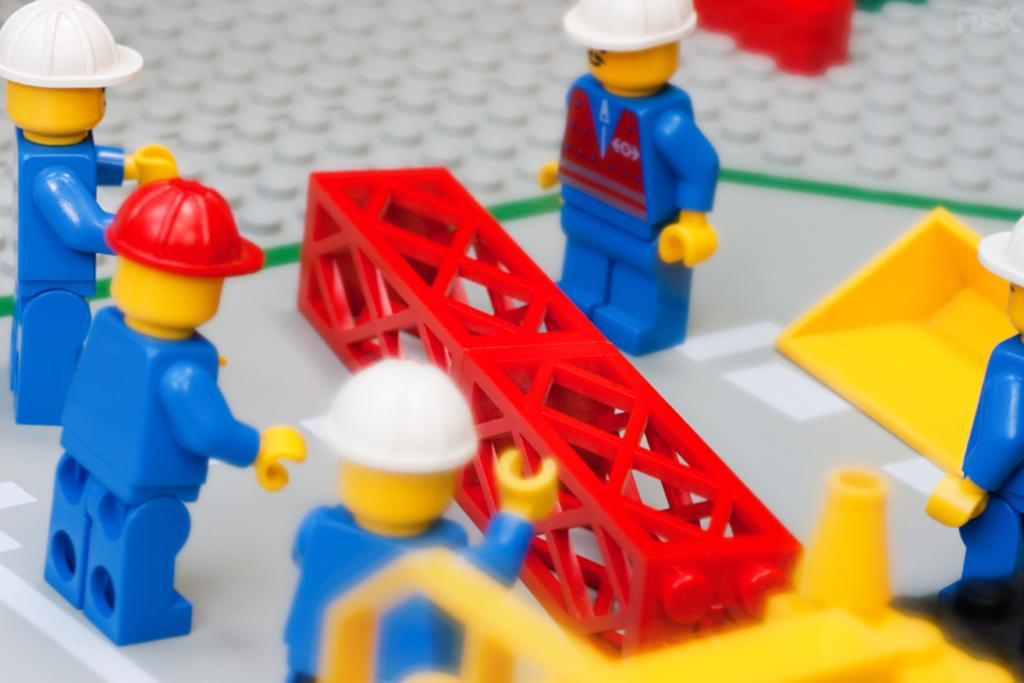Could you give a brief overview of what you see in this image? In the image in the center we can see different toys in blue and yellow color. And in middle there is a red color pole type structure. And we can see toys wearing different color caps and holding some yellow color object. 